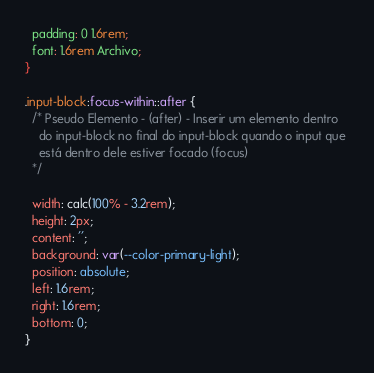Convert code to text. <code><loc_0><loc_0><loc_500><loc_500><_CSS_>  padding: 0 1.6rem;
  font: 1.6rem Archivo;
}

.input-block:focus-within::after {
  /* Pseudo Elemento - (after) - Inserir um elemento dentro
    do input-block no final do input-block quando o input que 
    está dentro dele estiver focado (focus)
  */

  width: calc(100% - 3.2rem);
  height: 2px;
  content: '';
  background: var(--color-primary-light);
  position: absolute;
  left: 1.6rem;
  right: 1.6rem;
  bottom: 0;
}</code> 